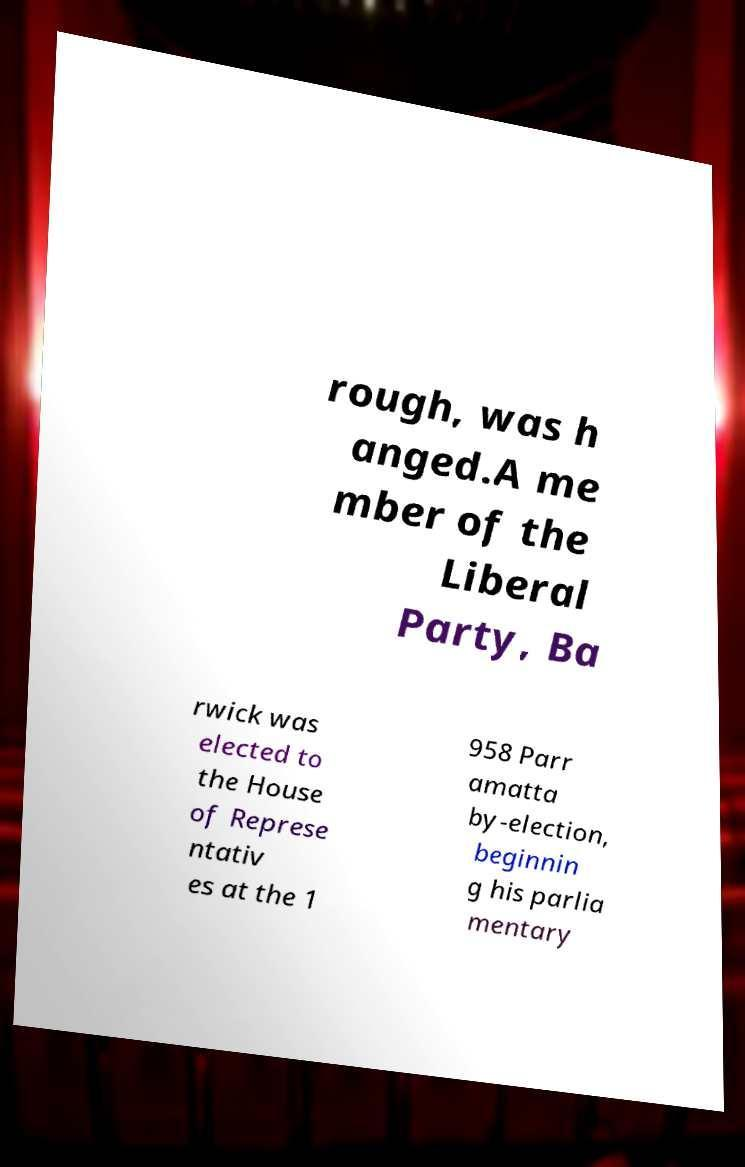Can you read and provide the text displayed in the image?This photo seems to have some interesting text. Can you extract and type it out for me? rough, was h anged.A me mber of the Liberal Party, Ba rwick was elected to the House of Represe ntativ es at the 1 958 Parr amatta by-election, beginnin g his parlia mentary 